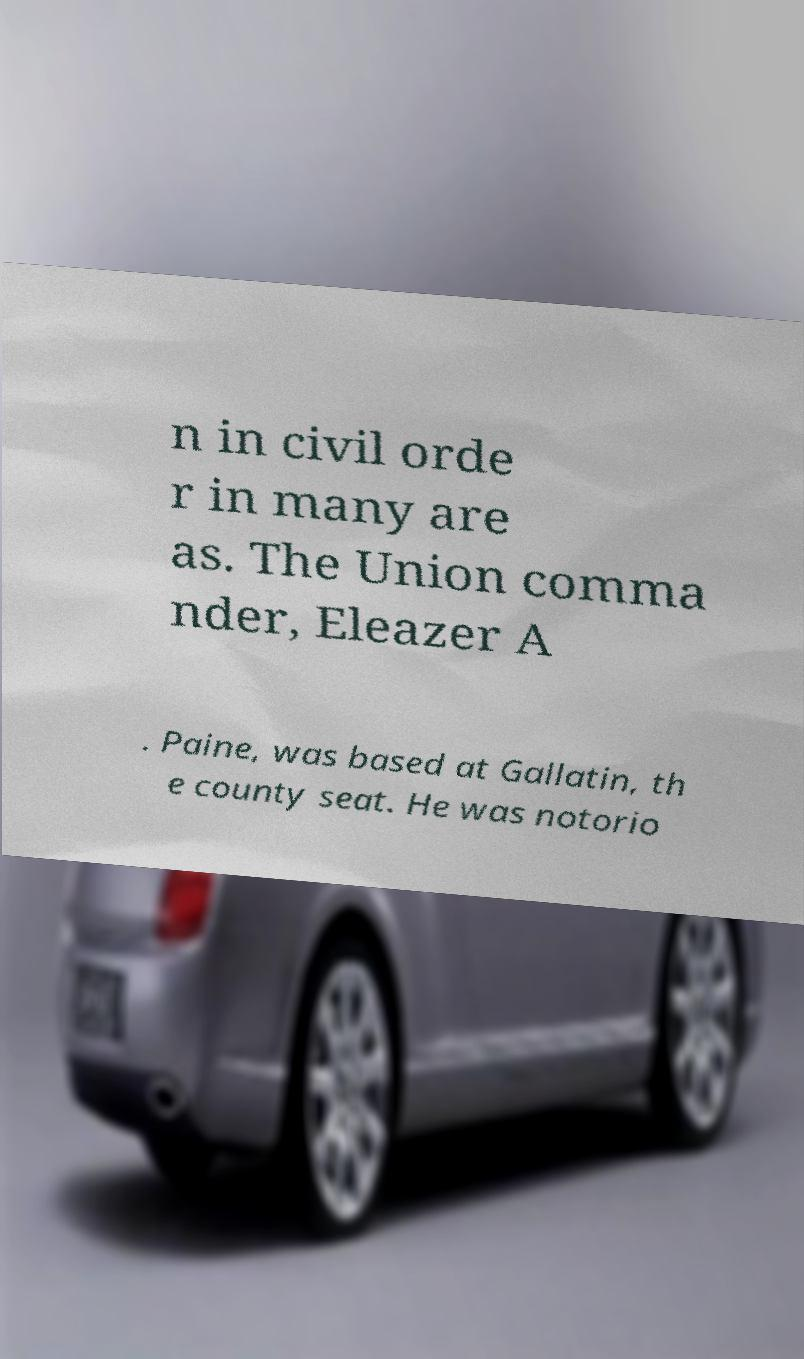For documentation purposes, I need the text within this image transcribed. Could you provide that? n in civil orde r in many are as. The Union comma nder, Eleazer A . Paine, was based at Gallatin, th e county seat. He was notorio 